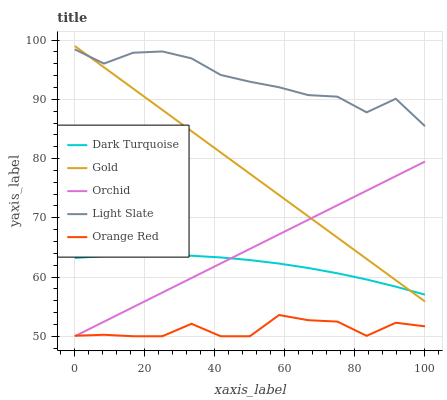Does Dark Turquoise have the minimum area under the curve?
Answer yes or no. No. Does Dark Turquoise have the maximum area under the curve?
Answer yes or no. No. Is Dark Turquoise the smoothest?
Answer yes or no. No. Is Dark Turquoise the roughest?
Answer yes or no. No. Does Dark Turquoise have the lowest value?
Answer yes or no. No. Does Dark Turquoise have the highest value?
Answer yes or no. No. Is Orange Red less than Light Slate?
Answer yes or no. Yes. Is Light Slate greater than Orchid?
Answer yes or no. Yes. Does Orange Red intersect Light Slate?
Answer yes or no. No. 